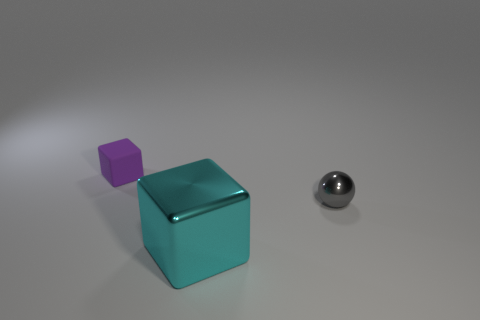Is there any other thing that is the same size as the metal block?
Your response must be concise. No. What number of yellow objects have the same shape as the purple object?
Ensure brevity in your answer.  0. There is a block behind the tiny thing in front of the purple rubber object; what number of cyan shiny things are in front of it?
Offer a very short reply. 1. How many small objects are right of the cyan object and on the left side of the small metal object?
Your answer should be compact. 0. Is there any other thing that has the same material as the purple cube?
Give a very brief answer. No. Is the big cube made of the same material as the purple object?
Your response must be concise. No. There is a tiny object that is to the right of the small object that is to the left of the large cyan metal cube on the left side of the gray metal object; what is its shape?
Your answer should be very brief. Sphere. Are there fewer big metal things that are behind the big cyan shiny block than big cyan things on the right side of the gray metallic ball?
Your answer should be compact. No. There is a small thing that is in front of the small thing that is behind the small shiny object; what shape is it?
Your answer should be compact. Sphere. Are there any other things that are the same color as the big cube?
Ensure brevity in your answer.  No. 